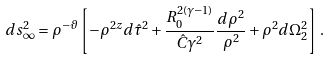Convert formula to latex. <formula><loc_0><loc_0><loc_500><loc_500>d s _ { \infty } ^ { 2 } = \rho ^ { - \vartheta } \left [ - \rho ^ { 2 z } d \hat { \tau } ^ { 2 } + \frac { R _ { 0 } ^ { 2 ( \gamma - 1 ) } } { \hat { C } \gamma ^ { 2 } } \frac { d \rho ^ { 2 } } { \rho ^ { 2 } } + \rho ^ { 2 } d \Omega _ { 2 } ^ { 2 } \right ] \, .</formula> 